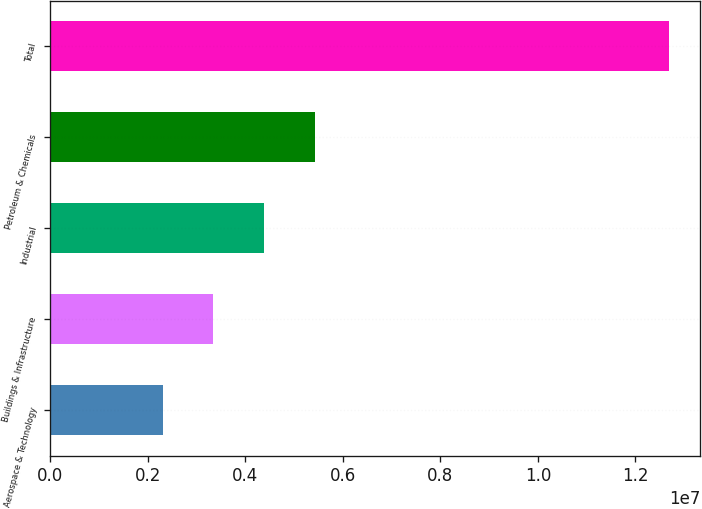Convert chart to OTSL. <chart><loc_0><loc_0><loc_500><loc_500><bar_chart><fcel>Aerospace & Technology<fcel>Buildings & Infrastructure<fcel>Industrial<fcel>Petroleum & Chemicals<fcel>Total<nl><fcel>2.30645e+06<fcel>3.34532e+06<fcel>4.38419e+06<fcel>5.42306e+06<fcel>1.26952e+07<nl></chart> 